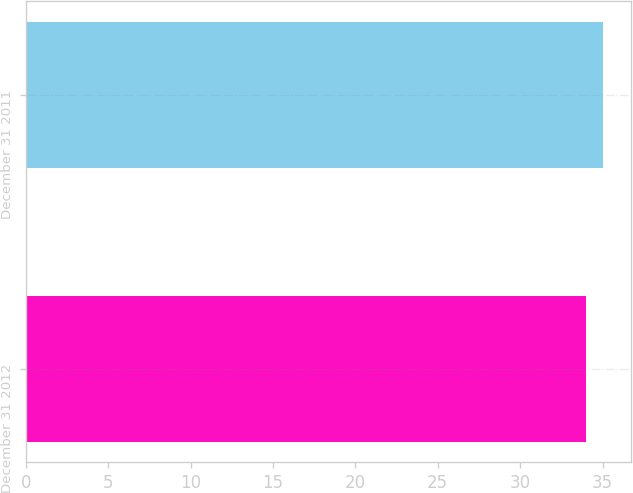<chart> <loc_0><loc_0><loc_500><loc_500><bar_chart><fcel>December 31 2012<fcel>December 31 2011<nl><fcel>34<fcel>35<nl></chart> 